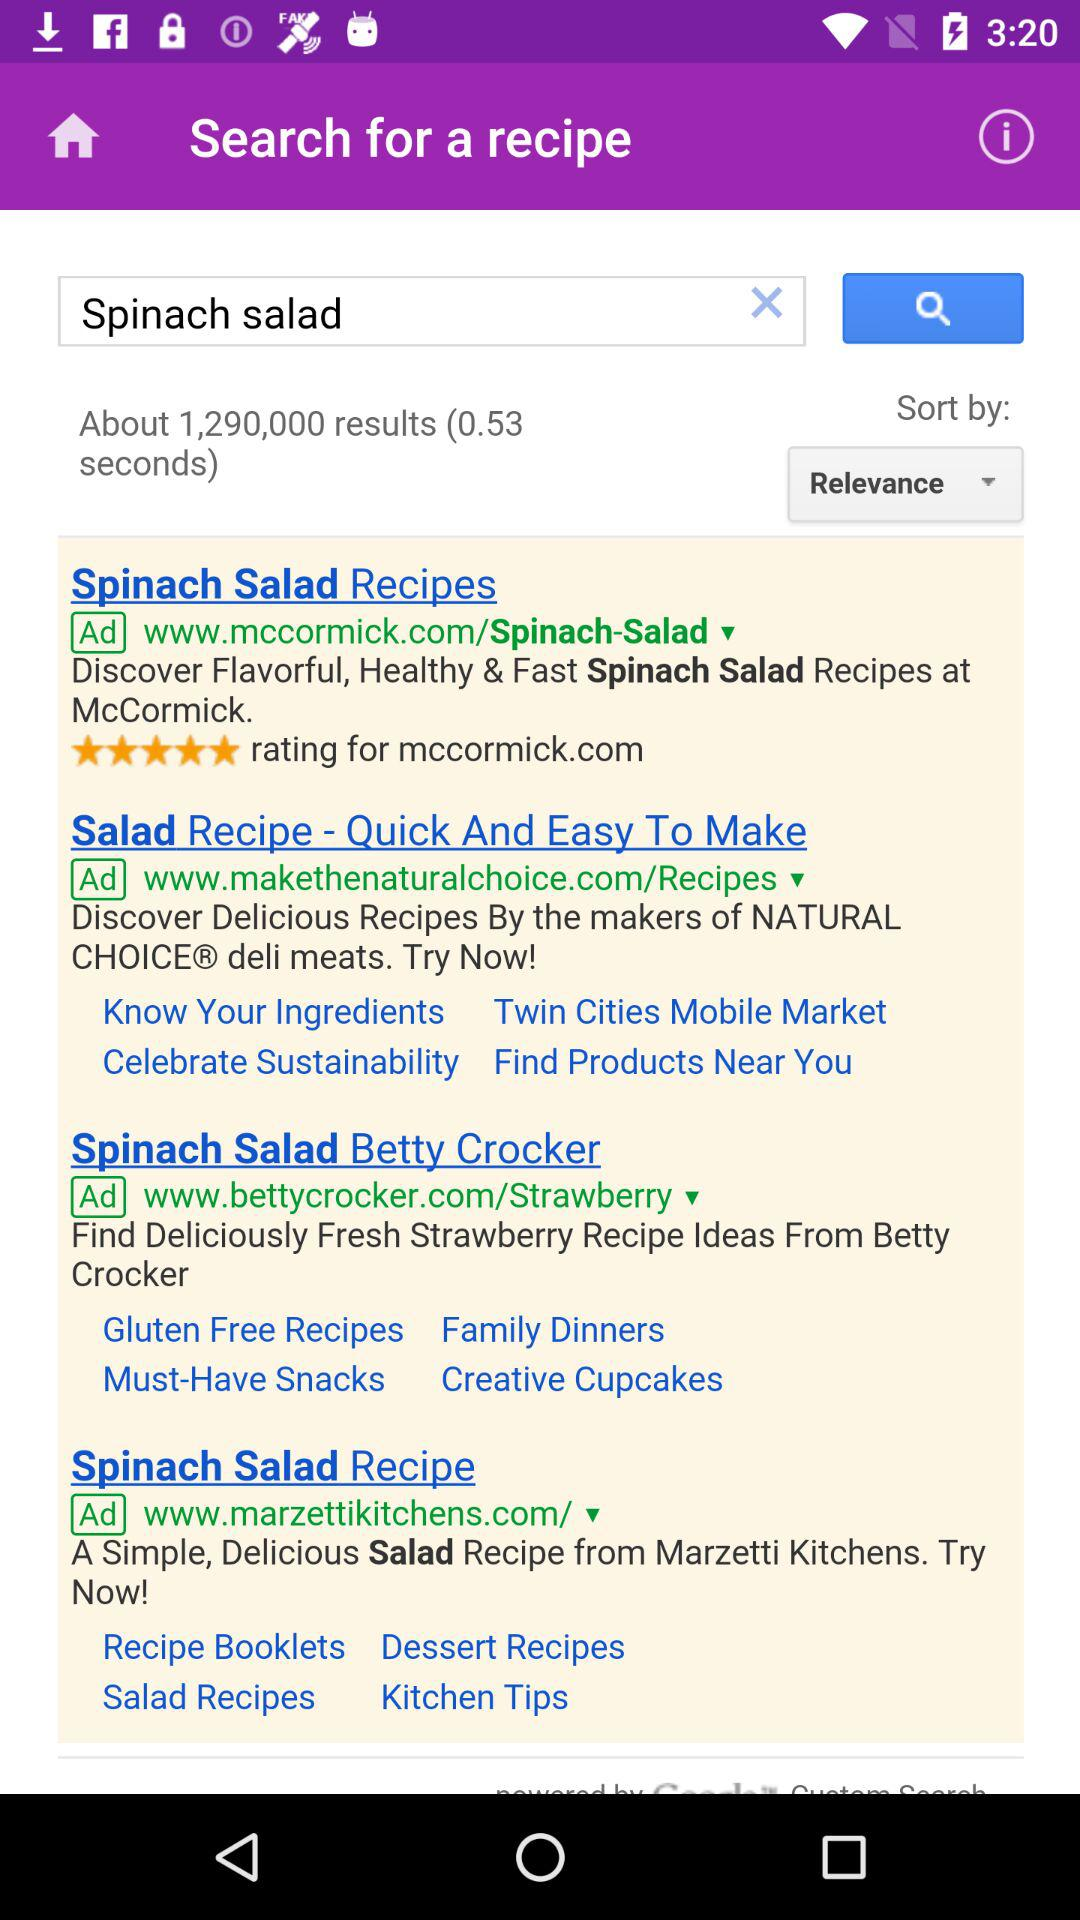What is written in the search bar? In the search bar, "Spinach salad" is written. 